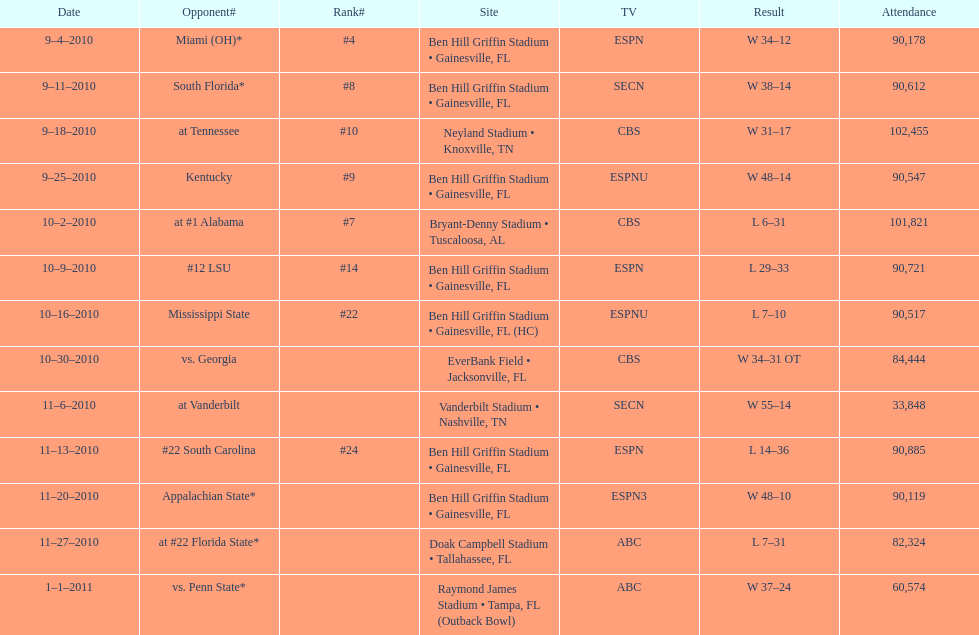How many successive weeks did the gators win before experiencing their first loss in the 2010 season? 4. 